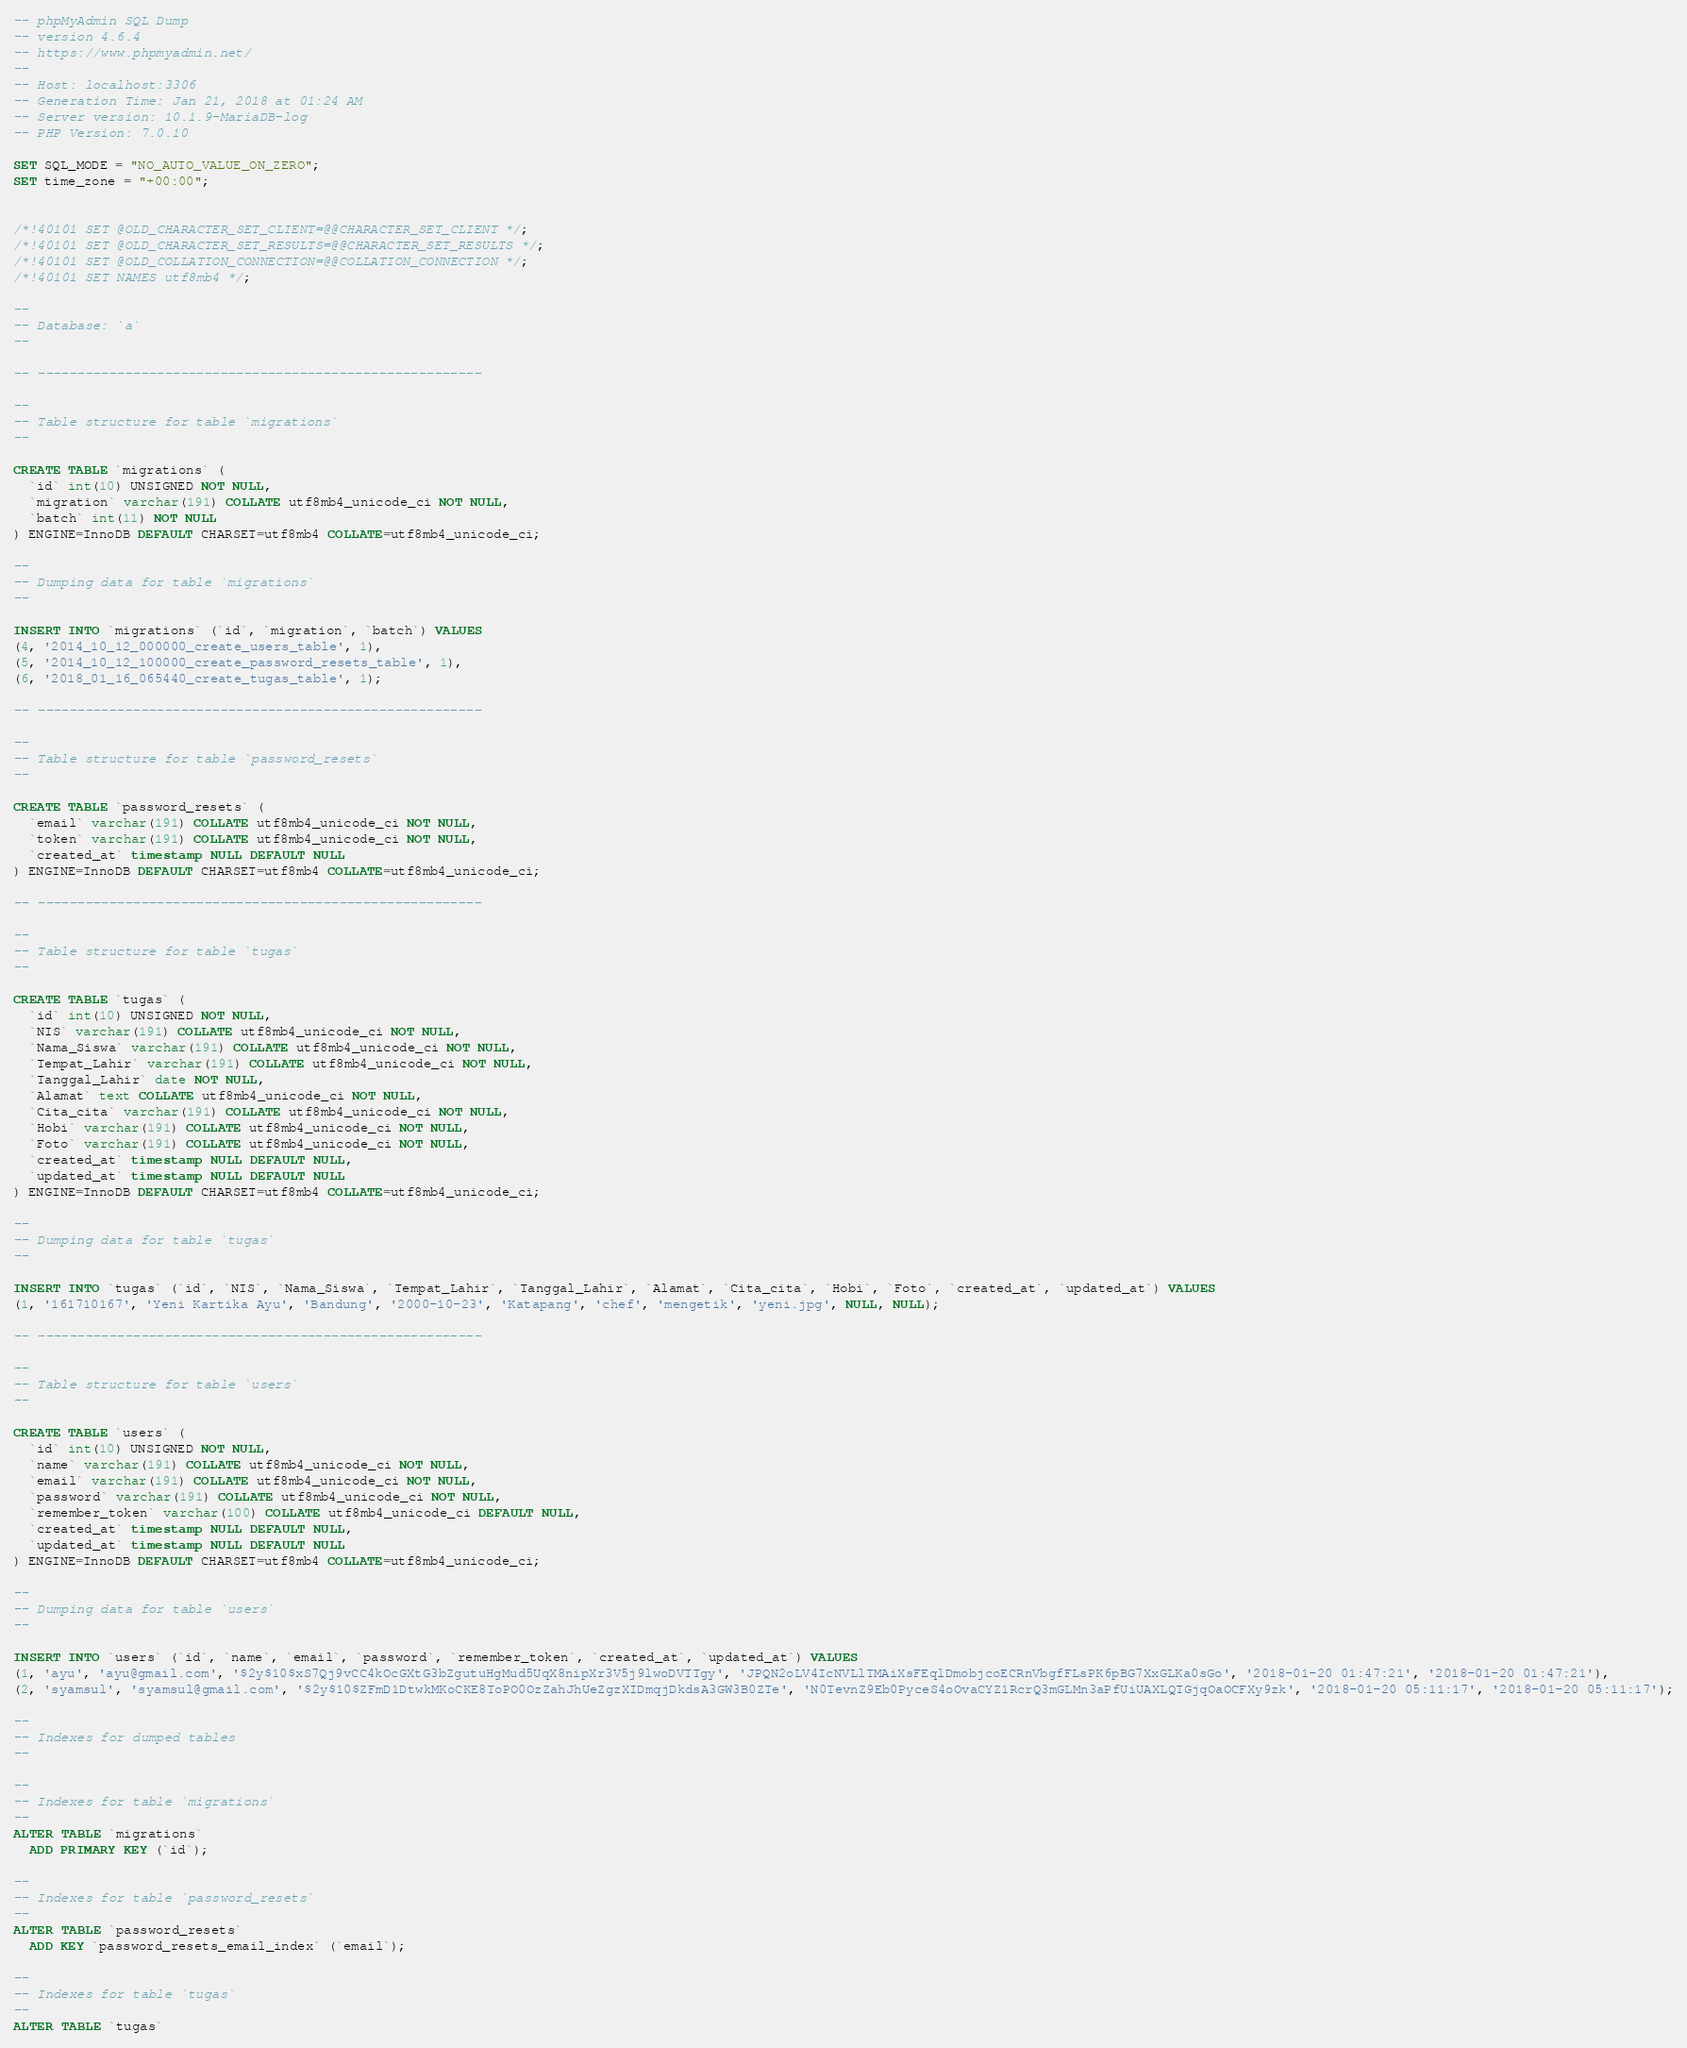Convert code to text. <code><loc_0><loc_0><loc_500><loc_500><_SQL_>-- phpMyAdmin SQL Dump
-- version 4.6.4
-- https://www.phpmyadmin.net/
--
-- Host: localhost:3306
-- Generation Time: Jan 21, 2018 at 01:24 AM
-- Server version: 10.1.9-MariaDB-log
-- PHP Version: 7.0.10

SET SQL_MODE = "NO_AUTO_VALUE_ON_ZERO";
SET time_zone = "+00:00";


/*!40101 SET @OLD_CHARACTER_SET_CLIENT=@@CHARACTER_SET_CLIENT */;
/*!40101 SET @OLD_CHARACTER_SET_RESULTS=@@CHARACTER_SET_RESULTS */;
/*!40101 SET @OLD_COLLATION_CONNECTION=@@COLLATION_CONNECTION */;
/*!40101 SET NAMES utf8mb4 */;

--
-- Database: `a`
--

-- --------------------------------------------------------

--
-- Table structure for table `migrations`
--

CREATE TABLE `migrations` (
  `id` int(10) UNSIGNED NOT NULL,
  `migration` varchar(191) COLLATE utf8mb4_unicode_ci NOT NULL,
  `batch` int(11) NOT NULL
) ENGINE=InnoDB DEFAULT CHARSET=utf8mb4 COLLATE=utf8mb4_unicode_ci;

--
-- Dumping data for table `migrations`
--

INSERT INTO `migrations` (`id`, `migration`, `batch`) VALUES
(4, '2014_10_12_000000_create_users_table', 1),
(5, '2014_10_12_100000_create_password_resets_table', 1),
(6, '2018_01_16_065440_create_tugas_table', 1);

-- --------------------------------------------------------

--
-- Table structure for table `password_resets`
--

CREATE TABLE `password_resets` (
  `email` varchar(191) COLLATE utf8mb4_unicode_ci NOT NULL,
  `token` varchar(191) COLLATE utf8mb4_unicode_ci NOT NULL,
  `created_at` timestamp NULL DEFAULT NULL
) ENGINE=InnoDB DEFAULT CHARSET=utf8mb4 COLLATE=utf8mb4_unicode_ci;

-- --------------------------------------------------------

--
-- Table structure for table `tugas`
--

CREATE TABLE `tugas` (
  `id` int(10) UNSIGNED NOT NULL,
  `NIS` varchar(191) COLLATE utf8mb4_unicode_ci NOT NULL,
  `Nama_Siswa` varchar(191) COLLATE utf8mb4_unicode_ci NOT NULL,
  `Tempat_Lahir` varchar(191) COLLATE utf8mb4_unicode_ci NOT NULL,
  `Tanggal_Lahir` date NOT NULL,
  `Alamat` text COLLATE utf8mb4_unicode_ci NOT NULL,
  `Cita_cita` varchar(191) COLLATE utf8mb4_unicode_ci NOT NULL,
  `Hobi` varchar(191) COLLATE utf8mb4_unicode_ci NOT NULL,
  `Foto` varchar(191) COLLATE utf8mb4_unicode_ci NOT NULL,
  `created_at` timestamp NULL DEFAULT NULL,
  `updated_at` timestamp NULL DEFAULT NULL
) ENGINE=InnoDB DEFAULT CHARSET=utf8mb4 COLLATE=utf8mb4_unicode_ci;

--
-- Dumping data for table `tugas`
--

INSERT INTO `tugas` (`id`, `NIS`, `Nama_Siswa`, `Tempat_Lahir`, `Tanggal_Lahir`, `Alamat`, `Cita_cita`, `Hobi`, `Foto`, `created_at`, `updated_at`) VALUES
(1, '161710167', 'Yeni Kartika Ayu', 'Bandung', '2000-10-23', 'Katapang', 'chef', 'mengetik', 'yeni.jpg', NULL, NULL);

-- --------------------------------------------------------

--
-- Table structure for table `users`
--

CREATE TABLE `users` (
  `id` int(10) UNSIGNED NOT NULL,
  `name` varchar(191) COLLATE utf8mb4_unicode_ci NOT NULL,
  `email` varchar(191) COLLATE utf8mb4_unicode_ci NOT NULL,
  `password` varchar(191) COLLATE utf8mb4_unicode_ci NOT NULL,
  `remember_token` varchar(100) COLLATE utf8mb4_unicode_ci DEFAULT NULL,
  `created_at` timestamp NULL DEFAULT NULL,
  `updated_at` timestamp NULL DEFAULT NULL
) ENGINE=InnoDB DEFAULT CHARSET=utf8mb4 COLLATE=utf8mb4_unicode_ci;

--
-- Dumping data for table `users`
--

INSERT INTO `users` (`id`, `name`, `email`, `password`, `remember_token`, `created_at`, `updated_at`) VALUES
(1, 'ayu', 'ayu@gmail.com', '$2y$10$xS7Qj9vCC4kOcGXtG3bZgutuHgMud5UqX8nipXr3V5j9lwoDVTTgy', 'JPQN2oLV4IcNVLlTMAiXsFEqlDmobjcoECRnVbgfFLsPK6pBG7XxGLKa0sGo', '2018-01-20 01:47:21', '2018-01-20 01:47:21'),
(2, 'syamsul', 'syamsul@gmail.com', '$2y$10$ZFmD1DtwkMKoCKE8ToPO0OzZahJhUeZgzXIDmqjDkdsA3GW3B0ZTe', 'N0TevnZ9Eb0PyceS4oOvaCYZ1RcrQ3mGLMn3aPfUiUAXLQTGjqOaOCFXy9zk', '2018-01-20 05:11:17', '2018-01-20 05:11:17');

--
-- Indexes for dumped tables
--

--
-- Indexes for table `migrations`
--
ALTER TABLE `migrations`
  ADD PRIMARY KEY (`id`);

--
-- Indexes for table `password_resets`
--
ALTER TABLE `password_resets`
  ADD KEY `password_resets_email_index` (`email`);

--
-- Indexes for table `tugas`
--
ALTER TABLE `tugas`</code> 